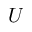Convert formula to latex. <formula><loc_0><loc_0><loc_500><loc_500>U</formula> 